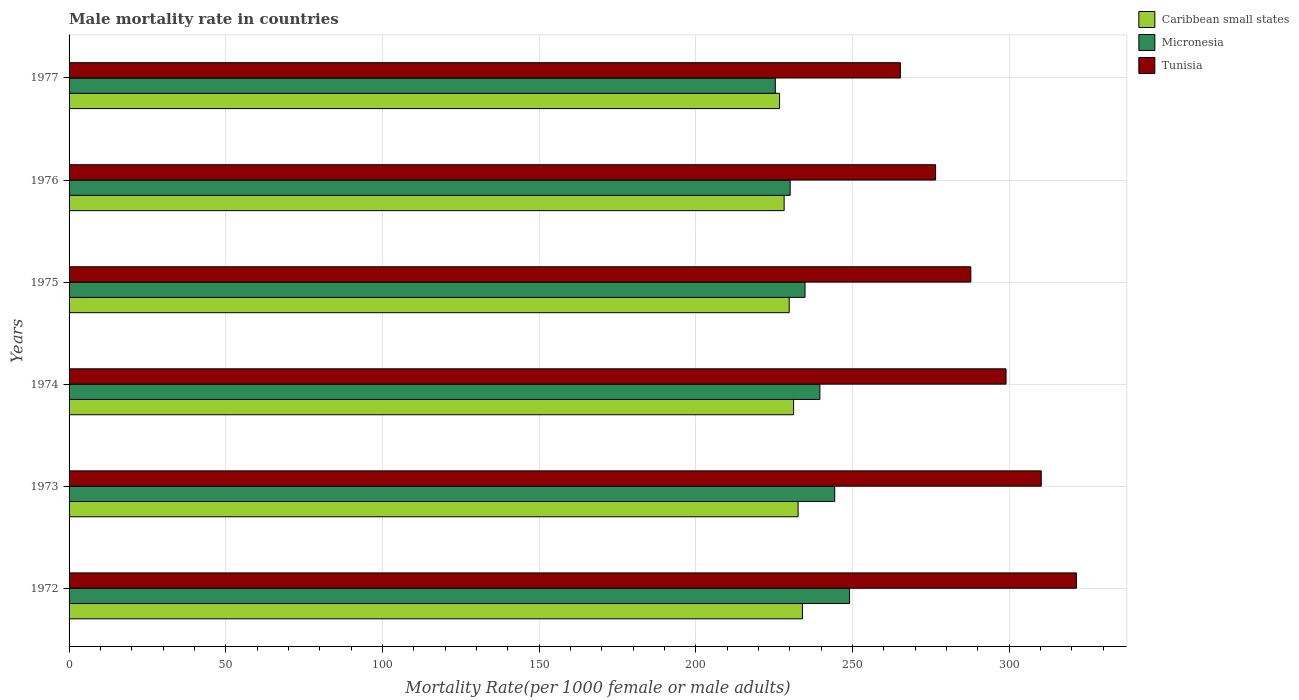How many groups of bars are there?
Your answer should be compact. 6. Are the number of bars on each tick of the Y-axis equal?
Make the answer very short. Yes. What is the male mortality rate in Tunisia in 1977?
Keep it short and to the point. 265.31. Across all years, what is the maximum male mortality rate in Caribbean small states?
Provide a short and direct response. 234.05. Across all years, what is the minimum male mortality rate in Caribbean small states?
Ensure brevity in your answer.  226.75. In which year was the male mortality rate in Tunisia maximum?
Ensure brevity in your answer.  1972. In which year was the male mortality rate in Caribbean small states minimum?
Your answer should be very brief. 1977. What is the total male mortality rate in Caribbean small states in the graph?
Your answer should be very brief. 1382.74. What is the difference between the male mortality rate in Caribbean small states in 1972 and that in 1977?
Give a very brief answer. 7.3. What is the difference between the male mortality rate in Caribbean small states in 1977 and the male mortality rate in Tunisia in 1973?
Keep it short and to the point. -83.52. What is the average male mortality rate in Tunisia per year?
Make the answer very short. 293.41. In the year 1977, what is the difference between the male mortality rate in Tunisia and male mortality rate in Micronesia?
Your answer should be compact. 39.92. In how many years, is the male mortality rate in Caribbean small states greater than 20 ?
Provide a short and direct response. 6. What is the ratio of the male mortality rate in Tunisia in 1975 to that in 1977?
Make the answer very short. 1.08. What is the difference between the highest and the second highest male mortality rate in Caribbean small states?
Your answer should be very brief. 1.39. What is the difference between the highest and the lowest male mortality rate in Micronesia?
Offer a terse response. 23.7. In how many years, is the male mortality rate in Caribbean small states greater than the average male mortality rate in Caribbean small states taken over all years?
Give a very brief answer. 3. Is the sum of the male mortality rate in Micronesia in 1974 and 1975 greater than the maximum male mortality rate in Caribbean small states across all years?
Offer a terse response. Yes. What does the 2nd bar from the top in 1974 represents?
Offer a terse response. Micronesia. What does the 3rd bar from the bottom in 1974 represents?
Offer a very short reply. Tunisia. Is it the case that in every year, the sum of the male mortality rate in Tunisia and male mortality rate in Caribbean small states is greater than the male mortality rate in Micronesia?
Ensure brevity in your answer.  Yes. How many years are there in the graph?
Your answer should be very brief. 6. Does the graph contain any zero values?
Your answer should be very brief. No. How many legend labels are there?
Keep it short and to the point. 3. How are the legend labels stacked?
Offer a terse response. Vertical. What is the title of the graph?
Your answer should be very brief. Male mortality rate in countries. What is the label or title of the X-axis?
Provide a short and direct response. Mortality Rate(per 1000 female or male adults). What is the label or title of the Y-axis?
Ensure brevity in your answer.  Years. What is the Mortality Rate(per 1000 female or male adults) in Caribbean small states in 1972?
Your answer should be compact. 234.05. What is the Mortality Rate(per 1000 female or male adults) in Micronesia in 1972?
Make the answer very short. 249.09. What is the Mortality Rate(per 1000 female or male adults) of Tunisia in 1972?
Provide a short and direct response. 321.5. What is the Mortality Rate(per 1000 female or male adults) of Caribbean small states in 1973?
Offer a very short reply. 232.67. What is the Mortality Rate(per 1000 female or male adults) of Micronesia in 1973?
Your answer should be very brief. 244.35. What is the Mortality Rate(per 1000 female or male adults) of Tunisia in 1973?
Keep it short and to the point. 310.27. What is the Mortality Rate(per 1000 female or male adults) in Caribbean small states in 1974?
Make the answer very short. 231.24. What is the Mortality Rate(per 1000 female or male adults) of Micronesia in 1974?
Your answer should be compact. 239.62. What is the Mortality Rate(per 1000 female or male adults) of Tunisia in 1974?
Give a very brief answer. 299.03. What is the Mortality Rate(per 1000 female or male adults) in Caribbean small states in 1975?
Ensure brevity in your answer.  229.82. What is the Mortality Rate(per 1000 female or male adults) of Micronesia in 1975?
Keep it short and to the point. 234.88. What is the Mortality Rate(per 1000 female or male adults) of Tunisia in 1975?
Offer a terse response. 287.79. What is the Mortality Rate(per 1000 female or male adults) of Caribbean small states in 1976?
Ensure brevity in your answer.  228.21. What is the Mortality Rate(per 1000 female or male adults) of Micronesia in 1976?
Your answer should be very brief. 230.14. What is the Mortality Rate(per 1000 female or male adults) in Tunisia in 1976?
Your answer should be very brief. 276.55. What is the Mortality Rate(per 1000 female or male adults) of Caribbean small states in 1977?
Provide a succinct answer. 226.75. What is the Mortality Rate(per 1000 female or male adults) of Micronesia in 1977?
Provide a short and direct response. 225.4. What is the Mortality Rate(per 1000 female or male adults) of Tunisia in 1977?
Offer a very short reply. 265.31. Across all years, what is the maximum Mortality Rate(per 1000 female or male adults) of Caribbean small states?
Keep it short and to the point. 234.05. Across all years, what is the maximum Mortality Rate(per 1000 female or male adults) in Micronesia?
Your answer should be compact. 249.09. Across all years, what is the maximum Mortality Rate(per 1000 female or male adults) in Tunisia?
Keep it short and to the point. 321.5. Across all years, what is the minimum Mortality Rate(per 1000 female or male adults) of Caribbean small states?
Offer a terse response. 226.75. Across all years, what is the minimum Mortality Rate(per 1000 female or male adults) in Micronesia?
Your answer should be compact. 225.4. Across all years, what is the minimum Mortality Rate(per 1000 female or male adults) of Tunisia?
Ensure brevity in your answer.  265.31. What is the total Mortality Rate(per 1000 female or male adults) in Caribbean small states in the graph?
Offer a very short reply. 1382.74. What is the total Mortality Rate(per 1000 female or male adults) of Micronesia in the graph?
Your answer should be very brief. 1423.47. What is the total Mortality Rate(per 1000 female or male adults) of Tunisia in the graph?
Make the answer very short. 1760.45. What is the difference between the Mortality Rate(per 1000 female or male adults) in Caribbean small states in 1972 and that in 1973?
Offer a terse response. 1.39. What is the difference between the Mortality Rate(per 1000 female or male adults) of Micronesia in 1972 and that in 1973?
Your answer should be very brief. 4.74. What is the difference between the Mortality Rate(per 1000 female or male adults) in Tunisia in 1972 and that in 1973?
Your answer should be compact. 11.24. What is the difference between the Mortality Rate(per 1000 female or male adults) in Caribbean small states in 1972 and that in 1974?
Make the answer very short. 2.82. What is the difference between the Mortality Rate(per 1000 female or male adults) in Micronesia in 1972 and that in 1974?
Make the answer very short. 9.48. What is the difference between the Mortality Rate(per 1000 female or male adults) in Tunisia in 1972 and that in 1974?
Ensure brevity in your answer.  22.48. What is the difference between the Mortality Rate(per 1000 female or male adults) in Caribbean small states in 1972 and that in 1975?
Ensure brevity in your answer.  4.23. What is the difference between the Mortality Rate(per 1000 female or male adults) in Micronesia in 1972 and that in 1975?
Your response must be concise. 14.22. What is the difference between the Mortality Rate(per 1000 female or male adults) of Tunisia in 1972 and that in 1975?
Keep it short and to the point. 33.72. What is the difference between the Mortality Rate(per 1000 female or male adults) in Caribbean small states in 1972 and that in 1976?
Keep it short and to the point. 5.84. What is the difference between the Mortality Rate(per 1000 female or male adults) of Micronesia in 1972 and that in 1976?
Offer a terse response. 18.96. What is the difference between the Mortality Rate(per 1000 female or male adults) of Tunisia in 1972 and that in 1976?
Your answer should be compact. 44.95. What is the difference between the Mortality Rate(per 1000 female or male adults) of Caribbean small states in 1972 and that in 1977?
Ensure brevity in your answer.  7.3. What is the difference between the Mortality Rate(per 1000 female or male adults) in Micronesia in 1972 and that in 1977?
Your response must be concise. 23.7. What is the difference between the Mortality Rate(per 1000 female or male adults) in Tunisia in 1972 and that in 1977?
Your answer should be very brief. 56.19. What is the difference between the Mortality Rate(per 1000 female or male adults) of Caribbean small states in 1973 and that in 1974?
Make the answer very short. 1.43. What is the difference between the Mortality Rate(per 1000 female or male adults) of Micronesia in 1973 and that in 1974?
Offer a terse response. 4.74. What is the difference between the Mortality Rate(per 1000 female or male adults) of Tunisia in 1973 and that in 1974?
Ensure brevity in your answer.  11.24. What is the difference between the Mortality Rate(per 1000 female or male adults) in Caribbean small states in 1973 and that in 1975?
Your answer should be very brief. 2.84. What is the difference between the Mortality Rate(per 1000 female or male adults) of Micronesia in 1973 and that in 1975?
Give a very brief answer. 9.48. What is the difference between the Mortality Rate(per 1000 female or male adults) of Tunisia in 1973 and that in 1975?
Provide a succinct answer. 22.48. What is the difference between the Mortality Rate(per 1000 female or male adults) of Caribbean small states in 1973 and that in 1976?
Make the answer very short. 4.46. What is the difference between the Mortality Rate(per 1000 female or male adults) of Micronesia in 1973 and that in 1976?
Offer a terse response. 14.22. What is the difference between the Mortality Rate(per 1000 female or male adults) of Tunisia in 1973 and that in 1976?
Give a very brief answer. 33.72. What is the difference between the Mortality Rate(per 1000 female or male adults) of Caribbean small states in 1973 and that in 1977?
Offer a very short reply. 5.92. What is the difference between the Mortality Rate(per 1000 female or male adults) of Micronesia in 1973 and that in 1977?
Provide a succinct answer. 18.96. What is the difference between the Mortality Rate(per 1000 female or male adults) in Tunisia in 1973 and that in 1977?
Keep it short and to the point. 44.95. What is the difference between the Mortality Rate(per 1000 female or male adults) in Caribbean small states in 1974 and that in 1975?
Offer a terse response. 1.41. What is the difference between the Mortality Rate(per 1000 female or male adults) of Micronesia in 1974 and that in 1975?
Ensure brevity in your answer.  4.74. What is the difference between the Mortality Rate(per 1000 female or male adults) of Tunisia in 1974 and that in 1975?
Your answer should be very brief. 11.24. What is the difference between the Mortality Rate(per 1000 female or male adults) in Caribbean small states in 1974 and that in 1976?
Offer a very short reply. 3.02. What is the difference between the Mortality Rate(per 1000 female or male adults) in Micronesia in 1974 and that in 1976?
Ensure brevity in your answer.  9.48. What is the difference between the Mortality Rate(per 1000 female or male adults) of Tunisia in 1974 and that in 1976?
Make the answer very short. 22.48. What is the difference between the Mortality Rate(per 1000 female or male adults) of Caribbean small states in 1974 and that in 1977?
Provide a succinct answer. 4.48. What is the difference between the Mortality Rate(per 1000 female or male adults) of Micronesia in 1974 and that in 1977?
Offer a very short reply. 14.22. What is the difference between the Mortality Rate(per 1000 female or male adults) of Tunisia in 1974 and that in 1977?
Ensure brevity in your answer.  33.72. What is the difference between the Mortality Rate(per 1000 female or male adults) in Caribbean small states in 1975 and that in 1976?
Your response must be concise. 1.61. What is the difference between the Mortality Rate(per 1000 female or male adults) of Micronesia in 1975 and that in 1976?
Keep it short and to the point. 4.74. What is the difference between the Mortality Rate(per 1000 female or male adults) of Tunisia in 1975 and that in 1976?
Provide a succinct answer. 11.24. What is the difference between the Mortality Rate(per 1000 female or male adults) in Caribbean small states in 1975 and that in 1977?
Provide a succinct answer. 3.07. What is the difference between the Mortality Rate(per 1000 female or male adults) in Micronesia in 1975 and that in 1977?
Ensure brevity in your answer.  9.48. What is the difference between the Mortality Rate(per 1000 female or male adults) in Tunisia in 1975 and that in 1977?
Your answer should be very brief. 22.48. What is the difference between the Mortality Rate(per 1000 female or male adults) in Caribbean small states in 1976 and that in 1977?
Keep it short and to the point. 1.46. What is the difference between the Mortality Rate(per 1000 female or male adults) of Micronesia in 1976 and that in 1977?
Offer a very short reply. 4.74. What is the difference between the Mortality Rate(per 1000 female or male adults) in Tunisia in 1976 and that in 1977?
Your answer should be compact. 11.24. What is the difference between the Mortality Rate(per 1000 female or male adults) in Caribbean small states in 1972 and the Mortality Rate(per 1000 female or male adults) in Micronesia in 1973?
Your answer should be compact. -10.3. What is the difference between the Mortality Rate(per 1000 female or male adults) of Caribbean small states in 1972 and the Mortality Rate(per 1000 female or male adults) of Tunisia in 1973?
Provide a succinct answer. -76.21. What is the difference between the Mortality Rate(per 1000 female or male adults) of Micronesia in 1972 and the Mortality Rate(per 1000 female or male adults) of Tunisia in 1973?
Your answer should be compact. -61.17. What is the difference between the Mortality Rate(per 1000 female or male adults) of Caribbean small states in 1972 and the Mortality Rate(per 1000 female or male adults) of Micronesia in 1974?
Keep it short and to the point. -5.56. What is the difference between the Mortality Rate(per 1000 female or male adults) of Caribbean small states in 1972 and the Mortality Rate(per 1000 female or male adults) of Tunisia in 1974?
Provide a short and direct response. -64.97. What is the difference between the Mortality Rate(per 1000 female or male adults) of Micronesia in 1972 and the Mortality Rate(per 1000 female or male adults) of Tunisia in 1974?
Ensure brevity in your answer.  -49.93. What is the difference between the Mortality Rate(per 1000 female or male adults) in Caribbean small states in 1972 and the Mortality Rate(per 1000 female or male adults) in Micronesia in 1975?
Provide a short and direct response. -0.82. What is the difference between the Mortality Rate(per 1000 female or male adults) in Caribbean small states in 1972 and the Mortality Rate(per 1000 female or male adults) in Tunisia in 1975?
Provide a succinct answer. -53.74. What is the difference between the Mortality Rate(per 1000 female or male adults) in Micronesia in 1972 and the Mortality Rate(per 1000 female or male adults) in Tunisia in 1975?
Provide a short and direct response. -38.7. What is the difference between the Mortality Rate(per 1000 female or male adults) of Caribbean small states in 1972 and the Mortality Rate(per 1000 female or male adults) of Micronesia in 1976?
Make the answer very short. 3.92. What is the difference between the Mortality Rate(per 1000 female or male adults) of Caribbean small states in 1972 and the Mortality Rate(per 1000 female or male adults) of Tunisia in 1976?
Your answer should be compact. -42.5. What is the difference between the Mortality Rate(per 1000 female or male adults) of Micronesia in 1972 and the Mortality Rate(per 1000 female or male adults) of Tunisia in 1976?
Provide a short and direct response. -27.46. What is the difference between the Mortality Rate(per 1000 female or male adults) of Caribbean small states in 1972 and the Mortality Rate(per 1000 female or male adults) of Micronesia in 1977?
Provide a short and direct response. 8.66. What is the difference between the Mortality Rate(per 1000 female or male adults) of Caribbean small states in 1972 and the Mortality Rate(per 1000 female or male adults) of Tunisia in 1977?
Your response must be concise. -31.26. What is the difference between the Mortality Rate(per 1000 female or male adults) of Micronesia in 1972 and the Mortality Rate(per 1000 female or male adults) of Tunisia in 1977?
Your response must be concise. -16.22. What is the difference between the Mortality Rate(per 1000 female or male adults) in Caribbean small states in 1973 and the Mortality Rate(per 1000 female or male adults) in Micronesia in 1974?
Offer a terse response. -6.95. What is the difference between the Mortality Rate(per 1000 female or male adults) in Caribbean small states in 1973 and the Mortality Rate(per 1000 female or male adults) in Tunisia in 1974?
Your answer should be compact. -66.36. What is the difference between the Mortality Rate(per 1000 female or male adults) of Micronesia in 1973 and the Mortality Rate(per 1000 female or male adults) of Tunisia in 1974?
Ensure brevity in your answer.  -54.67. What is the difference between the Mortality Rate(per 1000 female or male adults) of Caribbean small states in 1973 and the Mortality Rate(per 1000 female or male adults) of Micronesia in 1975?
Offer a very short reply. -2.21. What is the difference between the Mortality Rate(per 1000 female or male adults) of Caribbean small states in 1973 and the Mortality Rate(per 1000 female or male adults) of Tunisia in 1975?
Make the answer very short. -55.12. What is the difference between the Mortality Rate(per 1000 female or male adults) in Micronesia in 1973 and the Mortality Rate(per 1000 female or male adults) in Tunisia in 1975?
Offer a very short reply. -43.44. What is the difference between the Mortality Rate(per 1000 female or male adults) in Caribbean small states in 1973 and the Mortality Rate(per 1000 female or male adults) in Micronesia in 1976?
Your response must be concise. 2.53. What is the difference between the Mortality Rate(per 1000 female or male adults) of Caribbean small states in 1973 and the Mortality Rate(per 1000 female or male adults) of Tunisia in 1976?
Keep it short and to the point. -43.88. What is the difference between the Mortality Rate(per 1000 female or male adults) in Micronesia in 1973 and the Mortality Rate(per 1000 female or male adults) in Tunisia in 1976?
Your answer should be very brief. -32.2. What is the difference between the Mortality Rate(per 1000 female or male adults) in Caribbean small states in 1973 and the Mortality Rate(per 1000 female or male adults) in Micronesia in 1977?
Provide a succinct answer. 7.27. What is the difference between the Mortality Rate(per 1000 female or male adults) in Caribbean small states in 1973 and the Mortality Rate(per 1000 female or male adults) in Tunisia in 1977?
Your answer should be compact. -32.65. What is the difference between the Mortality Rate(per 1000 female or male adults) in Micronesia in 1973 and the Mortality Rate(per 1000 female or male adults) in Tunisia in 1977?
Your answer should be compact. -20.96. What is the difference between the Mortality Rate(per 1000 female or male adults) of Caribbean small states in 1974 and the Mortality Rate(per 1000 female or male adults) of Micronesia in 1975?
Provide a succinct answer. -3.64. What is the difference between the Mortality Rate(per 1000 female or male adults) of Caribbean small states in 1974 and the Mortality Rate(per 1000 female or male adults) of Tunisia in 1975?
Offer a terse response. -56.55. What is the difference between the Mortality Rate(per 1000 female or male adults) of Micronesia in 1974 and the Mortality Rate(per 1000 female or male adults) of Tunisia in 1975?
Provide a succinct answer. -48.17. What is the difference between the Mortality Rate(per 1000 female or male adults) in Caribbean small states in 1974 and the Mortality Rate(per 1000 female or male adults) in Micronesia in 1976?
Offer a terse response. 1.1. What is the difference between the Mortality Rate(per 1000 female or male adults) in Caribbean small states in 1974 and the Mortality Rate(per 1000 female or male adults) in Tunisia in 1976?
Your answer should be very brief. -45.32. What is the difference between the Mortality Rate(per 1000 female or male adults) in Micronesia in 1974 and the Mortality Rate(per 1000 female or male adults) in Tunisia in 1976?
Keep it short and to the point. -36.94. What is the difference between the Mortality Rate(per 1000 female or male adults) of Caribbean small states in 1974 and the Mortality Rate(per 1000 female or male adults) of Micronesia in 1977?
Provide a short and direct response. 5.84. What is the difference between the Mortality Rate(per 1000 female or male adults) of Caribbean small states in 1974 and the Mortality Rate(per 1000 female or male adults) of Tunisia in 1977?
Provide a succinct answer. -34.08. What is the difference between the Mortality Rate(per 1000 female or male adults) of Micronesia in 1974 and the Mortality Rate(per 1000 female or male adults) of Tunisia in 1977?
Your answer should be compact. -25.7. What is the difference between the Mortality Rate(per 1000 female or male adults) of Caribbean small states in 1975 and the Mortality Rate(per 1000 female or male adults) of Micronesia in 1976?
Offer a very short reply. -0.31. What is the difference between the Mortality Rate(per 1000 female or male adults) of Caribbean small states in 1975 and the Mortality Rate(per 1000 female or male adults) of Tunisia in 1976?
Offer a terse response. -46.73. What is the difference between the Mortality Rate(per 1000 female or male adults) in Micronesia in 1975 and the Mortality Rate(per 1000 female or male adults) in Tunisia in 1976?
Your response must be concise. -41.67. What is the difference between the Mortality Rate(per 1000 female or male adults) in Caribbean small states in 1975 and the Mortality Rate(per 1000 female or male adults) in Micronesia in 1977?
Offer a terse response. 4.43. What is the difference between the Mortality Rate(per 1000 female or male adults) in Caribbean small states in 1975 and the Mortality Rate(per 1000 female or male adults) in Tunisia in 1977?
Give a very brief answer. -35.49. What is the difference between the Mortality Rate(per 1000 female or male adults) in Micronesia in 1975 and the Mortality Rate(per 1000 female or male adults) in Tunisia in 1977?
Offer a terse response. -30.44. What is the difference between the Mortality Rate(per 1000 female or male adults) of Caribbean small states in 1976 and the Mortality Rate(per 1000 female or male adults) of Micronesia in 1977?
Provide a succinct answer. 2.81. What is the difference between the Mortality Rate(per 1000 female or male adults) in Caribbean small states in 1976 and the Mortality Rate(per 1000 female or male adults) in Tunisia in 1977?
Provide a short and direct response. -37.1. What is the difference between the Mortality Rate(per 1000 female or male adults) of Micronesia in 1976 and the Mortality Rate(per 1000 female or male adults) of Tunisia in 1977?
Offer a terse response. -35.17. What is the average Mortality Rate(per 1000 female or male adults) of Caribbean small states per year?
Give a very brief answer. 230.46. What is the average Mortality Rate(per 1000 female or male adults) of Micronesia per year?
Provide a short and direct response. 237.25. What is the average Mortality Rate(per 1000 female or male adults) of Tunisia per year?
Your response must be concise. 293.41. In the year 1972, what is the difference between the Mortality Rate(per 1000 female or male adults) of Caribbean small states and Mortality Rate(per 1000 female or male adults) of Micronesia?
Keep it short and to the point. -15.04. In the year 1972, what is the difference between the Mortality Rate(per 1000 female or male adults) of Caribbean small states and Mortality Rate(per 1000 female or male adults) of Tunisia?
Provide a short and direct response. -87.45. In the year 1972, what is the difference between the Mortality Rate(per 1000 female or male adults) of Micronesia and Mortality Rate(per 1000 female or male adults) of Tunisia?
Offer a terse response. -72.41. In the year 1973, what is the difference between the Mortality Rate(per 1000 female or male adults) in Caribbean small states and Mortality Rate(per 1000 female or male adults) in Micronesia?
Your answer should be compact. -11.69. In the year 1973, what is the difference between the Mortality Rate(per 1000 female or male adults) in Caribbean small states and Mortality Rate(per 1000 female or male adults) in Tunisia?
Keep it short and to the point. -77.6. In the year 1973, what is the difference between the Mortality Rate(per 1000 female or male adults) in Micronesia and Mortality Rate(per 1000 female or male adults) in Tunisia?
Offer a terse response. -65.91. In the year 1974, what is the difference between the Mortality Rate(per 1000 female or male adults) of Caribbean small states and Mortality Rate(per 1000 female or male adults) of Micronesia?
Make the answer very short. -8.38. In the year 1974, what is the difference between the Mortality Rate(per 1000 female or male adults) in Caribbean small states and Mortality Rate(per 1000 female or male adults) in Tunisia?
Make the answer very short. -67.79. In the year 1974, what is the difference between the Mortality Rate(per 1000 female or male adults) in Micronesia and Mortality Rate(per 1000 female or male adults) in Tunisia?
Offer a terse response. -59.41. In the year 1975, what is the difference between the Mortality Rate(per 1000 female or male adults) of Caribbean small states and Mortality Rate(per 1000 female or male adults) of Micronesia?
Give a very brief answer. -5.05. In the year 1975, what is the difference between the Mortality Rate(per 1000 female or male adults) of Caribbean small states and Mortality Rate(per 1000 female or male adults) of Tunisia?
Your answer should be very brief. -57.96. In the year 1975, what is the difference between the Mortality Rate(per 1000 female or male adults) of Micronesia and Mortality Rate(per 1000 female or male adults) of Tunisia?
Offer a very short reply. -52.91. In the year 1976, what is the difference between the Mortality Rate(per 1000 female or male adults) in Caribbean small states and Mortality Rate(per 1000 female or male adults) in Micronesia?
Ensure brevity in your answer.  -1.93. In the year 1976, what is the difference between the Mortality Rate(per 1000 female or male adults) of Caribbean small states and Mortality Rate(per 1000 female or male adults) of Tunisia?
Your response must be concise. -48.34. In the year 1976, what is the difference between the Mortality Rate(per 1000 female or male adults) of Micronesia and Mortality Rate(per 1000 female or male adults) of Tunisia?
Your answer should be compact. -46.41. In the year 1977, what is the difference between the Mortality Rate(per 1000 female or male adults) in Caribbean small states and Mortality Rate(per 1000 female or male adults) in Micronesia?
Give a very brief answer. 1.35. In the year 1977, what is the difference between the Mortality Rate(per 1000 female or male adults) in Caribbean small states and Mortality Rate(per 1000 female or male adults) in Tunisia?
Give a very brief answer. -38.56. In the year 1977, what is the difference between the Mortality Rate(per 1000 female or male adults) of Micronesia and Mortality Rate(per 1000 female or male adults) of Tunisia?
Keep it short and to the point. -39.91. What is the ratio of the Mortality Rate(per 1000 female or male adults) in Caribbean small states in 1972 to that in 1973?
Make the answer very short. 1.01. What is the ratio of the Mortality Rate(per 1000 female or male adults) of Micronesia in 1972 to that in 1973?
Your answer should be very brief. 1.02. What is the ratio of the Mortality Rate(per 1000 female or male adults) of Tunisia in 1972 to that in 1973?
Your answer should be compact. 1.04. What is the ratio of the Mortality Rate(per 1000 female or male adults) of Caribbean small states in 1972 to that in 1974?
Offer a terse response. 1.01. What is the ratio of the Mortality Rate(per 1000 female or male adults) of Micronesia in 1972 to that in 1974?
Offer a very short reply. 1.04. What is the ratio of the Mortality Rate(per 1000 female or male adults) in Tunisia in 1972 to that in 1974?
Your answer should be compact. 1.08. What is the ratio of the Mortality Rate(per 1000 female or male adults) in Caribbean small states in 1972 to that in 1975?
Offer a terse response. 1.02. What is the ratio of the Mortality Rate(per 1000 female or male adults) in Micronesia in 1972 to that in 1975?
Your answer should be very brief. 1.06. What is the ratio of the Mortality Rate(per 1000 female or male adults) of Tunisia in 1972 to that in 1975?
Your answer should be very brief. 1.12. What is the ratio of the Mortality Rate(per 1000 female or male adults) of Caribbean small states in 1972 to that in 1976?
Give a very brief answer. 1.03. What is the ratio of the Mortality Rate(per 1000 female or male adults) of Micronesia in 1972 to that in 1976?
Your response must be concise. 1.08. What is the ratio of the Mortality Rate(per 1000 female or male adults) in Tunisia in 1972 to that in 1976?
Your response must be concise. 1.16. What is the ratio of the Mortality Rate(per 1000 female or male adults) of Caribbean small states in 1972 to that in 1977?
Offer a terse response. 1.03. What is the ratio of the Mortality Rate(per 1000 female or male adults) in Micronesia in 1972 to that in 1977?
Ensure brevity in your answer.  1.11. What is the ratio of the Mortality Rate(per 1000 female or male adults) in Tunisia in 1972 to that in 1977?
Give a very brief answer. 1.21. What is the ratio of the Mortality Rate(per 1000 female or male adults) of Micronesia in 1973 to that in 1974?
Provide a short and direct response. 1.02. What is the ratio of the Mortality Rate(per 1000 female or male adults) of Tunisia in 1973 to that in 1974?
Keep it short and to the point. 1.04. What is the ratio of the Mortality Rate(per 1000 female or male adults) of Caribbean small states in 1973 to that in 1975?
Your answer should be compact. 1.01. What is the ratio of the Mortality Rate(per 1000 female or male adults) in Micronesia in 1973 to that in 1975?
Offer a terse response. 1.04. What is the ratio of the Mortality Rate(per 1000 female or male adults) in Tunisia in 1973 to that in 1975?
Your response must be concise. 1.08. What is the ratio of the Mortality Rate(per 1000 female or male adults) in Caribbean small states in 1973 to that in 1976?
Provide a short and direct response. 1.02. What is the ratio of the Mortality Rate(per 1000 female or male adults) of Micronesia in 1973 to that in 1976?
Your answer should be compact. 1.06. What is the ratio of the Mortality Rate(per 1000 female or male adults) of Tunisia in 1973 to that in 1976?
Offer a terse response. 1.12. What is the ratio of the Mortality Rate(per 1000 female or male adults) in Caribbean small states in 1973 to that in 1977?
Your answer should be very brief. 1.03. What is the ratio of the Mortality Rate(per 1000 female or male adults) of Micronesia in 1973 to that in 1977?
Give a very brief answer. 1.08. What is the ratio of the Mortality Rate(per 1000 female or male adults) of Tunisia in 1973 to that in 1977?
Provide a succinct answer. 1.17. What is the ratio of the Mortality Rate(per 1000 female or male adults) of Micronesia in 1974 to that in 1975?
Ensure brevity in your answer.  1.02. What is the ratio of the Mortality Rate(per 1000 female or male adults) of Tunisia in 1974 to that in 1975?
Provide a short and direct response. 1.04. What is the ratio of the Mortality Rate(per 1000 female or male adults) in Caribbean small states in 1974 to that in 1976?
Your answer should be very brief. 1.01. What is the ratio of the Mortality Rate(per 1000 female or male adults) in Micronesia in 1974 to that in 1976?
Your response must be concise. 1.04. What is the ratio of the Mortality Rate(per 1000 female or male adults) of Tunisia in 1974 to that in 1976?
Provide a succinct answer. 1.08. What is the ratio of the Mortality Rate(per 1000 female or male adults) in Caribbean small states in 1974 to that in 1977?
Offer a terse response. 1.02. What is the ratio of the Mortality Rate(per 1000 female or male adults) of Micronesia in 1974 to that in 1977?
Keep it short and to the point. 1.06. What is the ratio of the Mortality Rate(per 1000 female or male adults) in Tunisia in 1974 to that in 1977?
Ensure brevity in your answer.  1.13. What is the ratio of the Mortality Rate(per 1000 female or male adults) in Caribbean small states in 1975 to that in 1976?
Make the answer very short. 1.01. What is the ratio of the Mortality Rate(per 1000 female or male adults) of Micronesia in 1975 to that in 1976?
Offer a very short reply. 1.02. What is the ratio of the Mortality Rate(per 1000 female or male adults) in Tunisia in 1975 to that in 1976?
Ensure brevity in your answer.  1.04. What is the ratio of the Mortality Rate(per 1000 female or male adults) in Caribbean small states in 1975 to that in 1977?
Give a very brief answer. 1.01. What is the ratio of the Mortality Rate(per 1000 female or male adults) in Micronesia in 1975 to that in 1977?
Keep it short and to the point. 1.04. What is the ratio of the Mortality Rate(per 1000 female or male adults) of Tunisia in 1975 to that in 1977?
Your answer should be compact. 1.08. What is the ratio of the Mortality Rate(per 1000 female or male adults) in Caribbean small states in 1976 to that in 1977?
Make the answer very short. 1.01. What is the ratio of the Mortality Rate(per 1000 female or male adults) in Tunisia in 1976 to that in 1977?
Your answer should be very brief. 1.04. What is the difference between the highest and the second highest Mortality Rate(per 1000 female or male adults) in Caribbean small states?
Offer a very short reply. 1.39. What is the difference between the highest and the second highest Mortality Rate(per 1000 female or male adults) in Micronesia?
Provide a short and direct response. 4.74. What is the difference between the highest and the second highest Mortality Rate(per 1000 female or male adults) in Tunisia?
Give a very brief answer. 11.24. What is the difference between the highest and the lowest Mortality Rate(per 1000 female or male adults) in Caribbean small states?
Your answer should be very brief. 7.3. What is the difference between the highest and the lowest Mortality Rate(per 1000 female or male adults) of Micronesia?
Offer a terse response. 23.7. What is the difference between the highest and the lowest Mortality Rate(per 1000 female or male adults) in Tunisia?
Your answer should be compact. 56.19. 